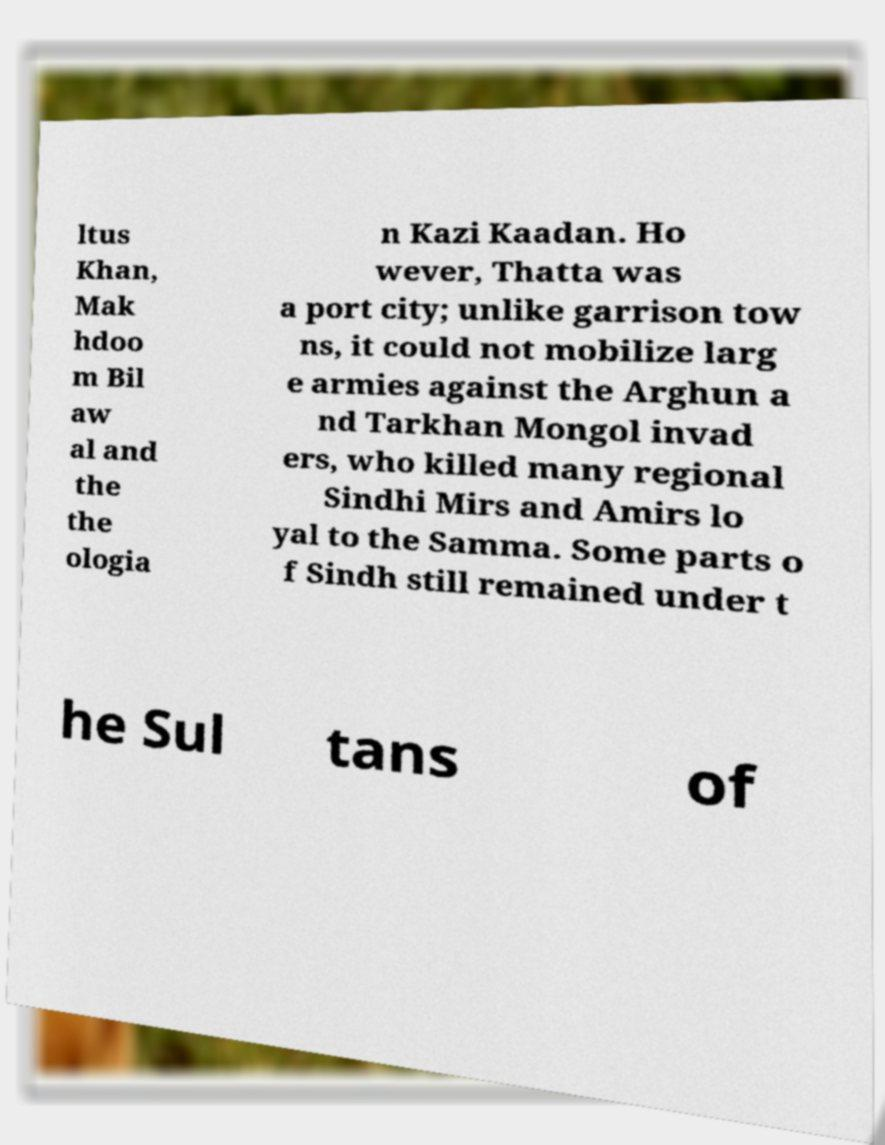I need the written content from this picture converted into text. Can you do that? ltus Khan, Mak hdoo m Bil aw al and the the ologia n Kazi Kaadan. Ho wever, Thatta was a port city; unlike garrison tow ns, it could not mobilize larg e armies against the Arghun a nd Tarkhan Mongol invad ers, who killed many regional Sindhi Mirs and Amirs lo yal to the Samma. Some parts o f Sindh still remained under t he Sul tans of 